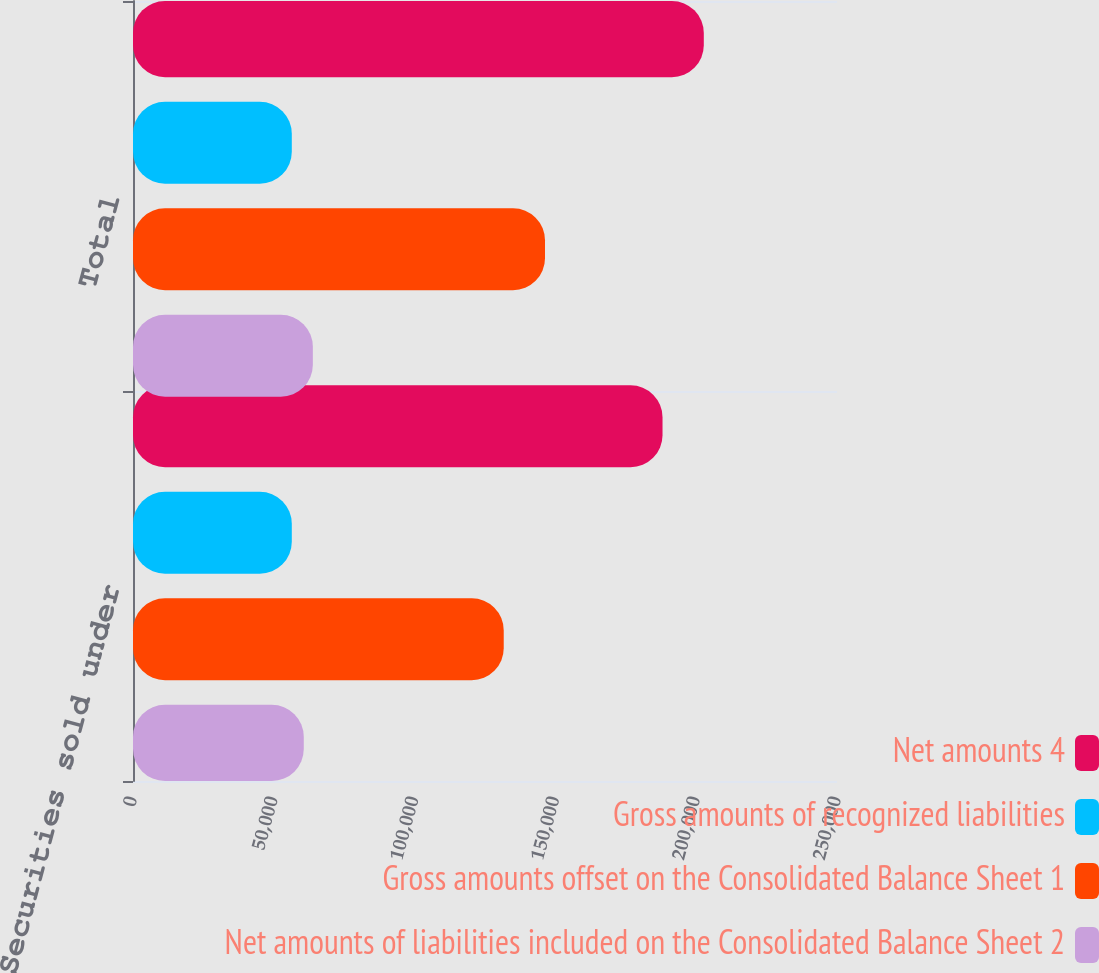Convert chart. <chart><loc_0><loc_0><loc_500><loc_500><stacked_bar_chart><ecel><fcel>Securities sold under<fcel>Total<nl><fcel>Net amounts 4<fcel>188040<fcel>202697<nl><fcel>Gross amounts of recognized liabilities<fcel>56390<fcel>56390<nl><fcel>Gross amounts offset on the Consolidated Balance Sheet 1<fcel>131650<fcel>146307<nl><fcel>Net amounts of liabilities included on the Consolidated Balance Sheet 2<fcel>60641<fcel>63867<nl></chart> 